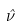Convert formula to latex. <formula><loc_0><loc_0><loc_500><loc_500>\hat { \nu }</formula> 